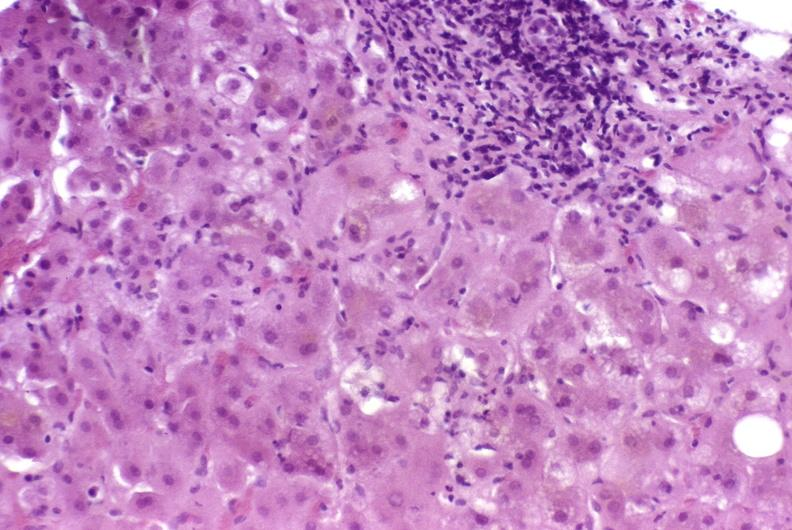what is present?
Answer the question using a single word or phrase. Liver 